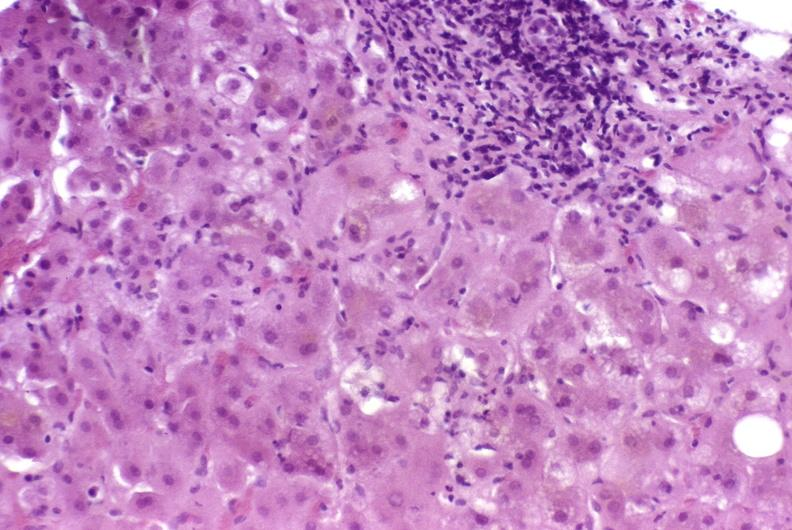what is present?
Answer the question using a single word or phrase. Liver 